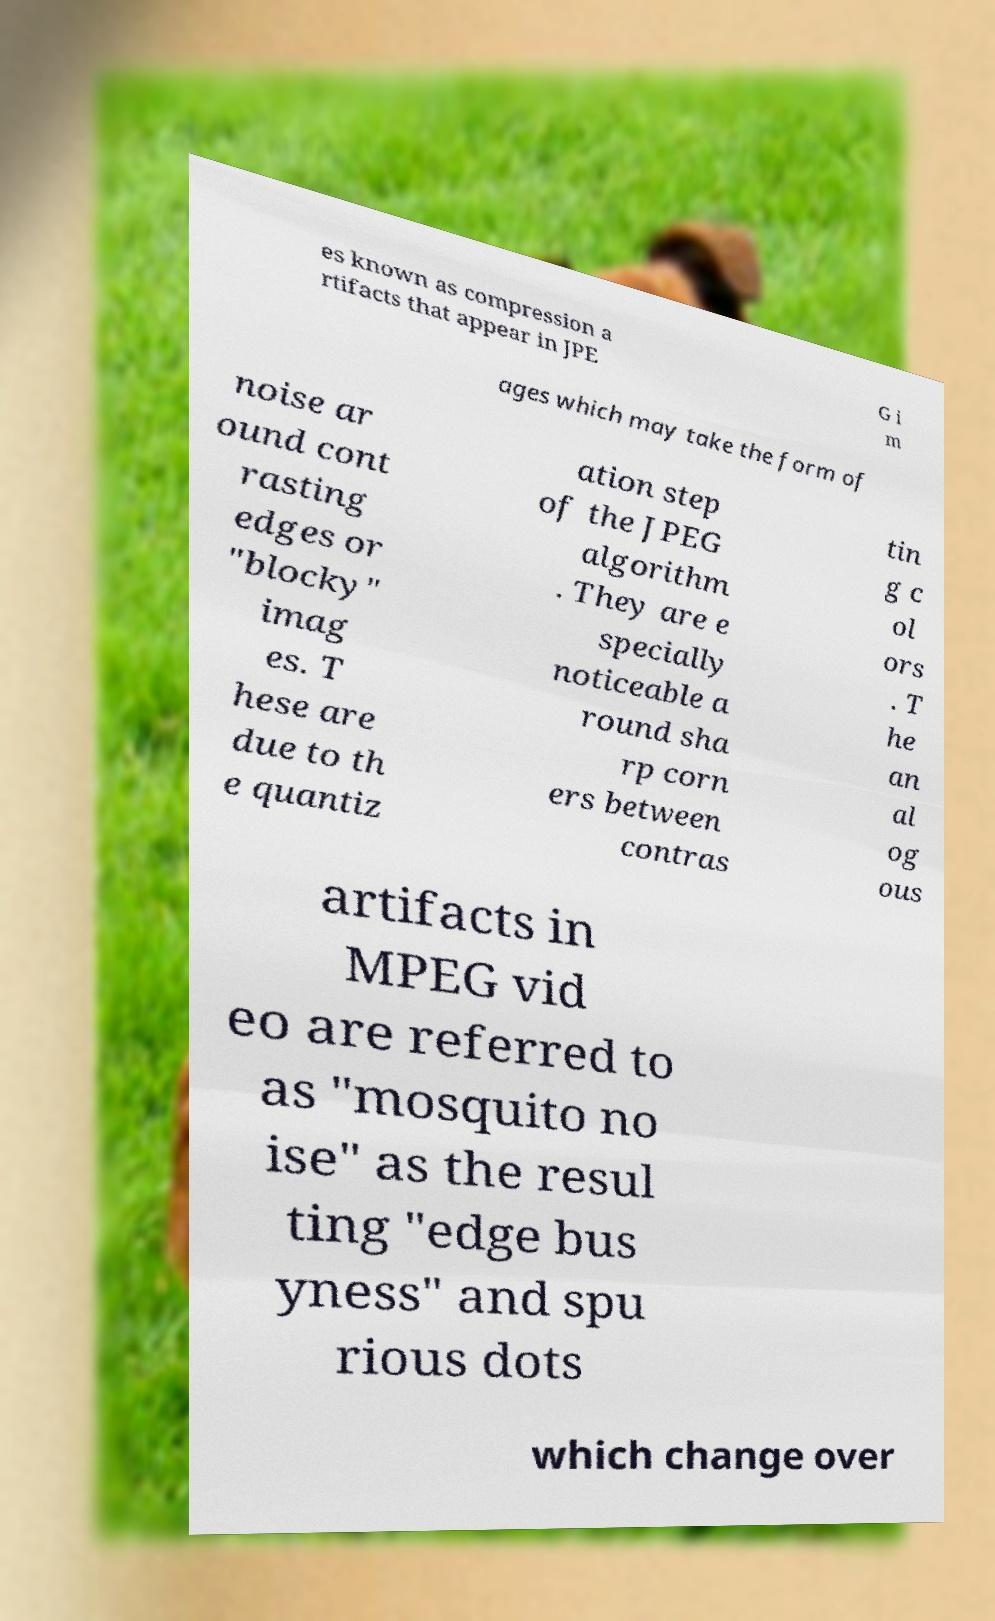For documentation purposes, I need the text within this image transcribed. Could you provide that? es known as compression a rtifacts that appear in JPE G i m ages which may take the form of noise ar ound cont rasting edges or "blocky" imag es. T hese are due to th e quantiz ation step of the JPEG algorithm . They are e specially noticeable a round sha rp corn ers between contras tin g c ol ors . T he an al og ous artifacts in MPEG vid eo are referred to as "mosquito no ise" as the resul ting "edge bus yness" and spu rious dots which change over 